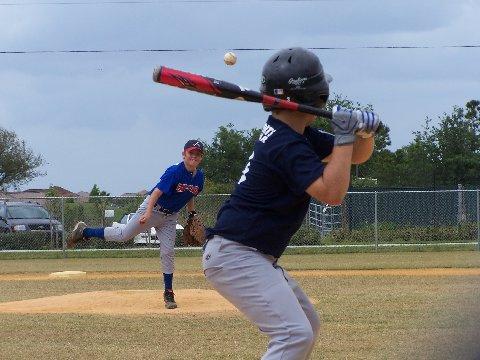Are the cars in the background parked?
Answer briefly. Yes. What sport is being played?
Quick response, please. Baseball. Where is the pitcher standing?
Answer briefly. Pitcher's mound. 